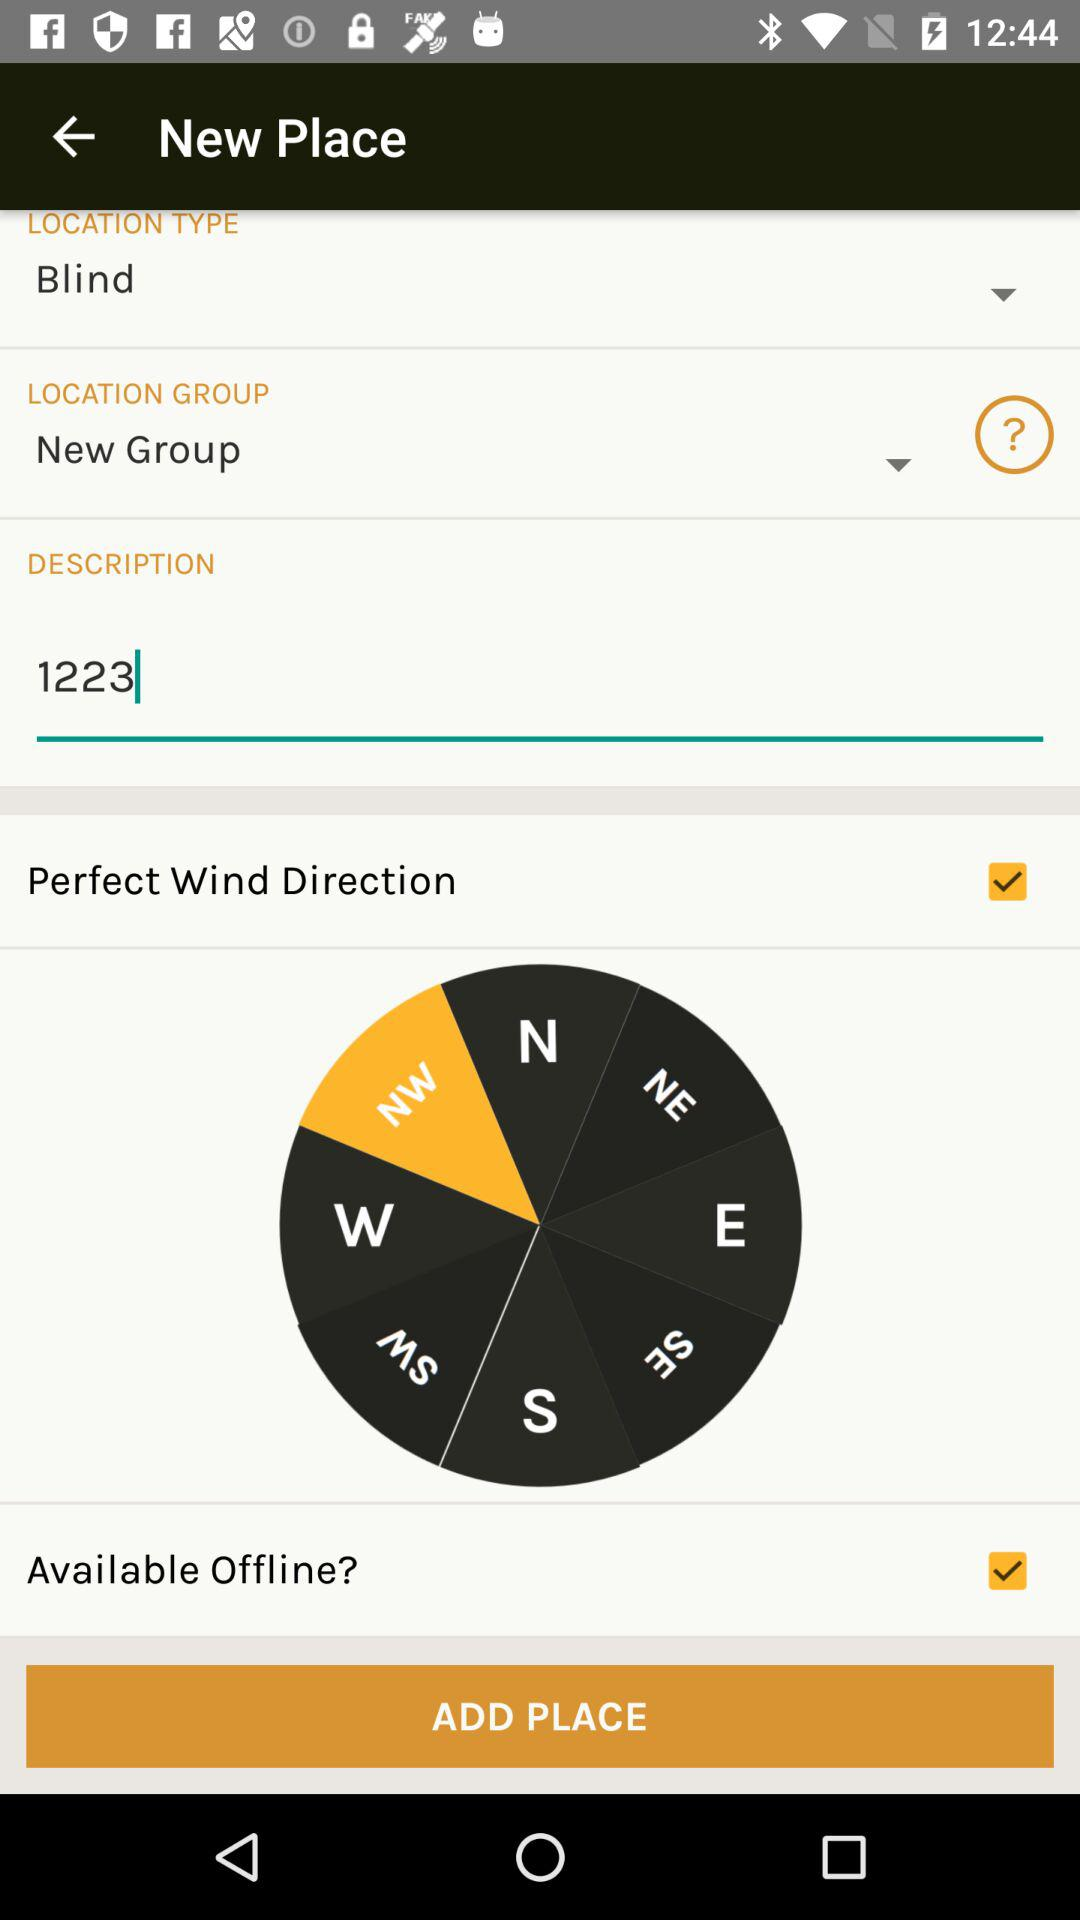What is the status of "Perfect Wind Direction"? The status of "Perfect Wind Direction" is "on". 